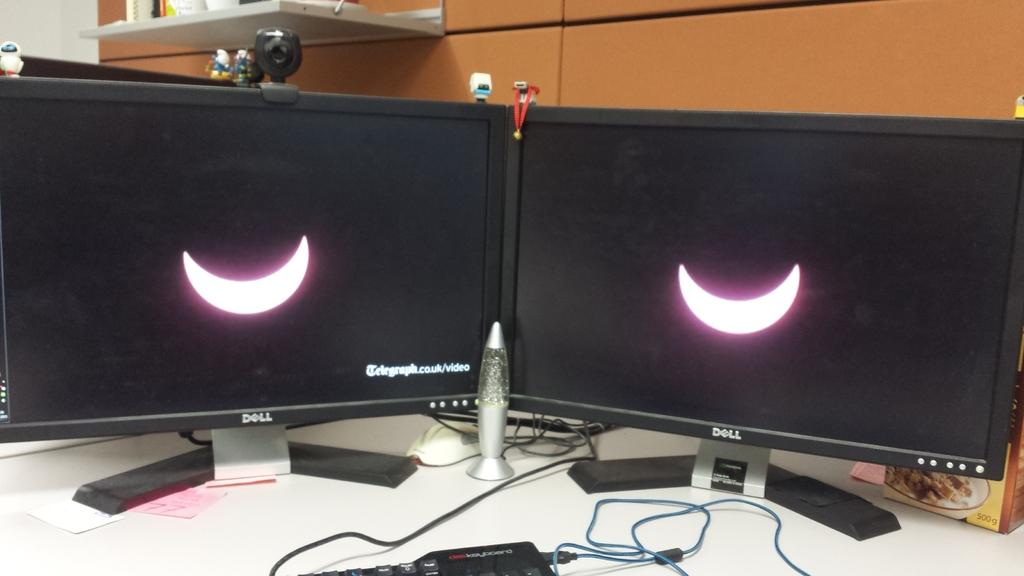<image>
Relay a brief, clear account of the picture shown. Two black monitors are side by side and they both say Dell. 